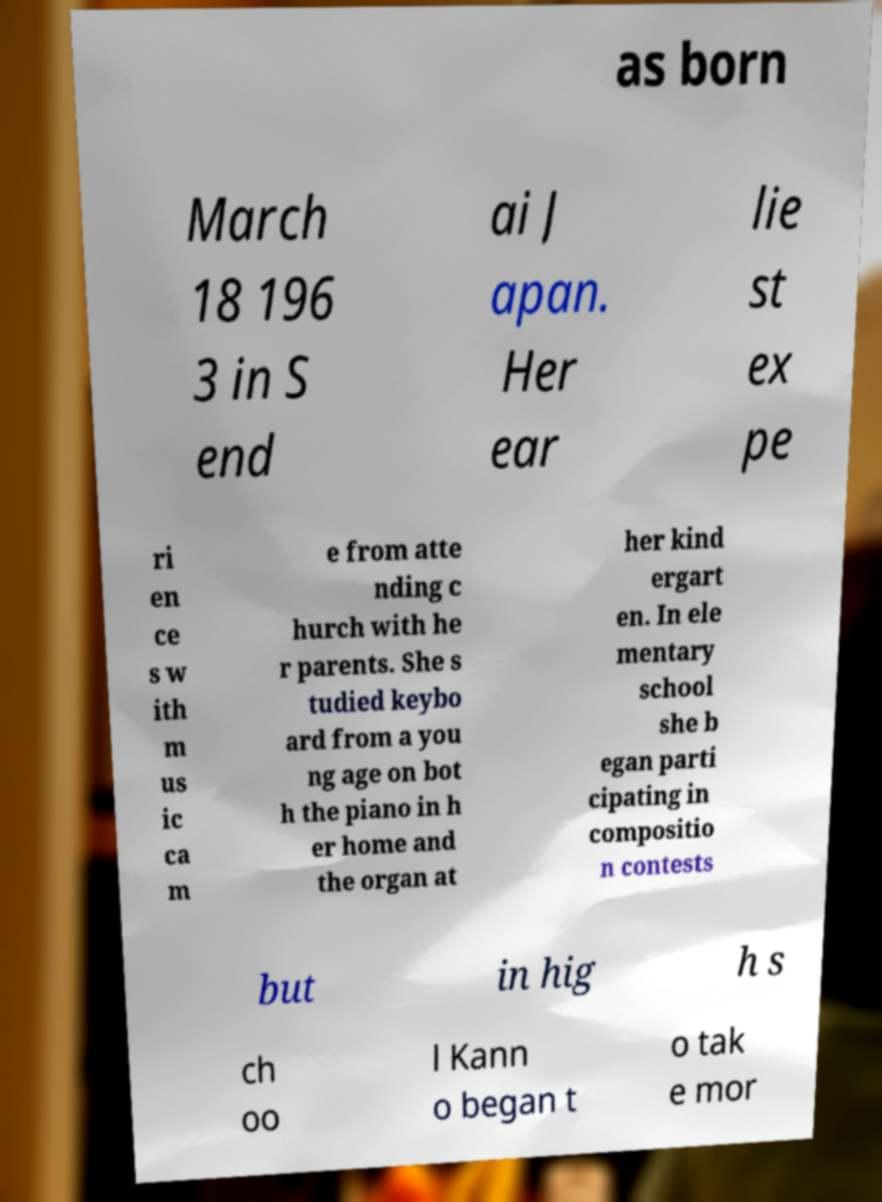What messages or text are displayed in this image? I need them in a readable, typed format. as born March 18 196 3 in S end ai J apan. Her ear lie st ex pe ri en ce s w ith m us ic ca m e from atte nding c hurch with he r parents. She s tudied keybo ard from a you ng age on bot h the piano in h er home and the organ at her kind ergart en. In ele mentary school she b egan parti cipating in compositio n contests but in hig h s ch oo l Kann o began t o tak e mor 